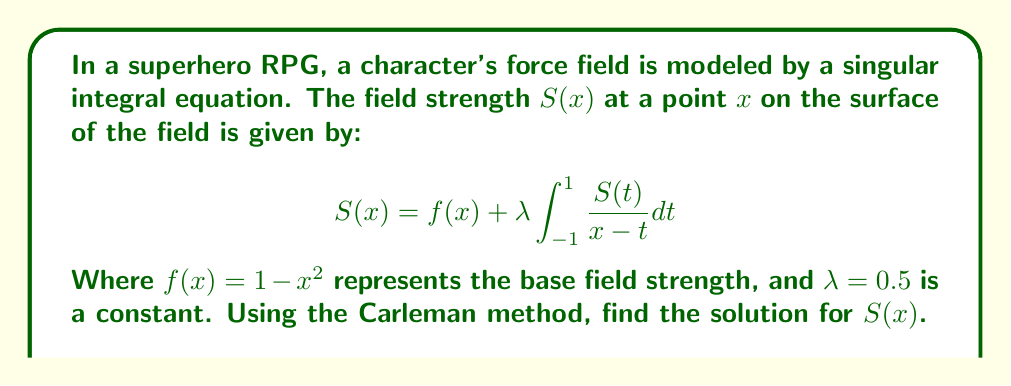Teach me how to tackle this problem. To solve this singular integral equation using the Carleman method:

1) First, we recognize this as a Cauchy-type singular integral equation.

2) The Carleman method involves transforming the equation into a Riemann-Hilbert problem. We introduce the complex function:

   $$\Phi(z) = \frac{1}{2\pi i} \int_{-1}^{1} \frac{S(t)}{t-z} dt$$

3) This function satisfies the Sokhotski-Plemelj formula:

   $$S(x) = \Phi^+(x) - \Phi^-(x)$$

   Where $\Phi^+(x)$ and $\Phi^-(x)$ are the limit values of $\Phi(z)$ as $z$ approaches $x$ from above and below the real axis respectively.

4) Substituting this into our original equation:

   $$\Phi^+(x) - \Phi^-(x) = 1 - x^2 + \lambda \pi i [\Phi^+(x) + \Phi^-(x)]$$

5) Rearranging:

   $$\Phi^+(x)(1-\lambda \pi i) = \Phi^-(x)(1+\lambda \pi i) + (1-x^2)$$

6) This is a Riemann-Hilbert problem. The solution is:

   $$\Phi(z) = \frac{X(z)}{2\pi i} \int_{-1}^{1} \frac{1-t^2}{(t-z)X^+(t)} dt$$

   Where $X(z) = (z+1)^{-1/2+i\alpha}(z-1)^{-1/2-i\alpha}$ and $\alpha = \frac{1}{2\pi}\ln\frac{1+\lambda\pi i}{1-\lambda\pi i}$

7) The solution for $S(x)$ is then:

   $$S(x) = \Phi^+(x) - \Phi^-(x) = \frac{X^+(x) - X^-(x)}{\pi i} \int_{-1}^{1} \frac{1-t^2}{(t-x)X^+(t)} dt$$

8) Simplifying with $\lambda = 0.5$:

   $$S(x) = \frac{2}{\pi}\sqrt{1-x^2} \int_{-1}^{1} \frac{1-t^2}{(t-x)\sqrt{1-t^2}} dt$$

This is the solution for the force field strength $S(x)$.
Answer: $$S(x) = \frac{2}{\pi}\sqrt{1-x^2} \int_{-1}^{1} \frac{1-t^2}{(t-x)\sqrt{1-t^2}} dt$$ 